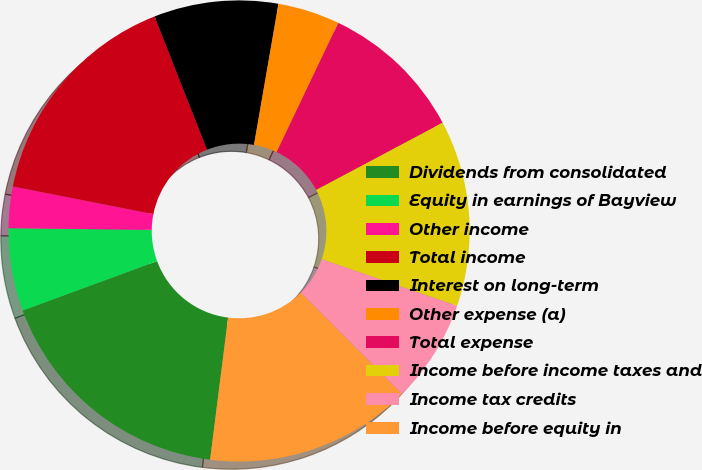Convert chart to OTSL. <chart><loc_0><loc_0><loc_500><loc_500><pie_chart><fcel>Dividends from consolidated<fcel>Equity in earnings of Bayview<fcel>Other income<fcel>Total income<fcel>Interest on long-term<fcel>Other expense (a)<fcel>Total expense<fcel>Income before income taxes and<fcel>Income tax credits<fcel>Income before equity in<nl><fcel>17.39%<fcel>5.8%<fcel>2.9%<fcel>15.94%<fcel>8.7%<fcel>4.35%<fcel>10.14%<fcel>13.04%<fcel>7.25%<fcel>14.49%<nl></chart> 